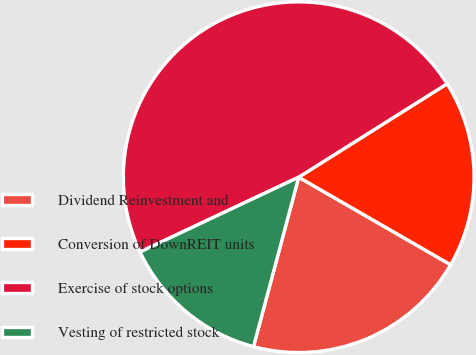Convert chart to OTSL. <chart><loc_0><loc_0><loc_500><loc_500><pie_chart><fcel>Dividend Reinvestment and<fcel>Conversion of DownREIT units<fcel>Exercise of stock options<fcel>Vesting of restricted stock<nl><fcel>20.83%<fcel>17.26%<fcel>48.06%<fcel>13.84%<nl></chart> 